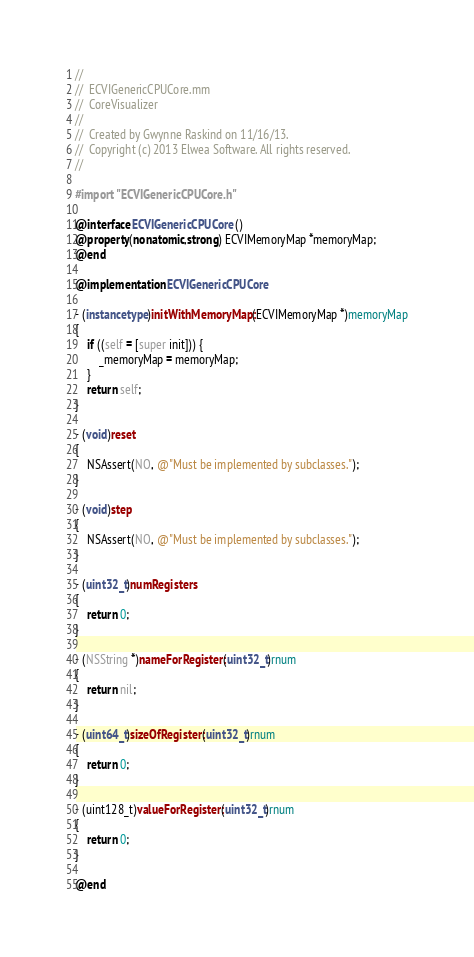<code> <loc_0><loc_0><loc_500><loc_500><_ObjectiveC_>//
//  ECVIGenericCPUCore.mm
//  CoreVisualizer
//
//  Created by Gwynne Raskind on 11/16/13.
//  Copyright (c) 2013 Elwea Software. All rights reserved.
//

#import "ECVIGenericCPUCore.h"

@interface ECVIGenericCPUCore ()
@property(nonatomic,strong) ECVIMemoryMap *memoryMap;
@end

@implementation ECVIGenericCPUCore

- (instancetype)initWithMemoryMap:(ECVIMemoryMap *)memoryMap
{
	if ((self = [super init])) {
		_memoryMap = memoryMap;
	}
	return self;
}

- (void)reset
{
	NSAssert(NO, @"Must be implemented by subclasses.");
}

- (void)step
{
	NSAssert(NO, @"Must be implemented by subclasses.");
}

- (uint32_t)numRegisters
{
	return 0;
}

- (NSString *)nameForRegister:(uint32_t)rnum
{
	return nil;
}

- (uint64_t)sizeOfRegister:(uint32_t)rnum
{
	return 0;
}

- (uint128_t)valueForRegister:(uint32_t)rnum
{
	return 0;
}

@end
</code> 